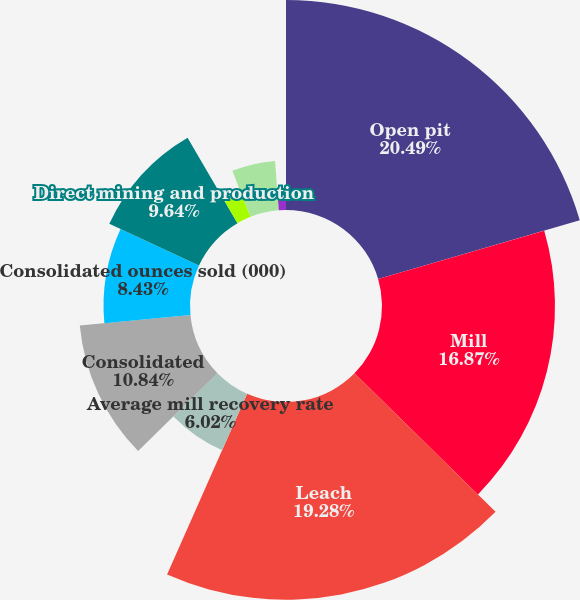Convert chart to OTSL. <chart><loc_0><loc_0><loc_500><loc_500><pie_chart><fcel>Open pit<fcel>Mill<fcel>Leach<fcel>Average mill recovery rate<fcel>Consolidated<fcel>Consolidated ounces sold (000)<fcel>Direct mining and production<fcel>By-product credits<fcel>Royalties and production taxes<fcel>Write-downs and inventory<nl><fcel>20.48%<fcel>16.87%<fcel>19.28%<fcel>6.02%<fcel>10.84%<fcel>8.43%<fcel>9.64%<fcel>2.41%<fcel>4.82%<fcel>1.2%<nl></chart> 